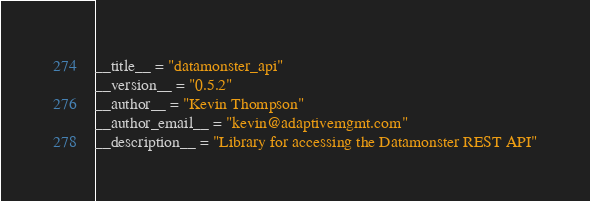Convert code to text. <code><loc_0><loc_0><loc_500><loc_500><_Python_>__title__ = "datamonster_api"
__version__ = "0.5.2"
__author__ = "Kevin Thompson"
__author_email__ = "kevin@adaptivemgmt.com"
__description__ = "Library for accessing the Datamonster REST API"
</code> 